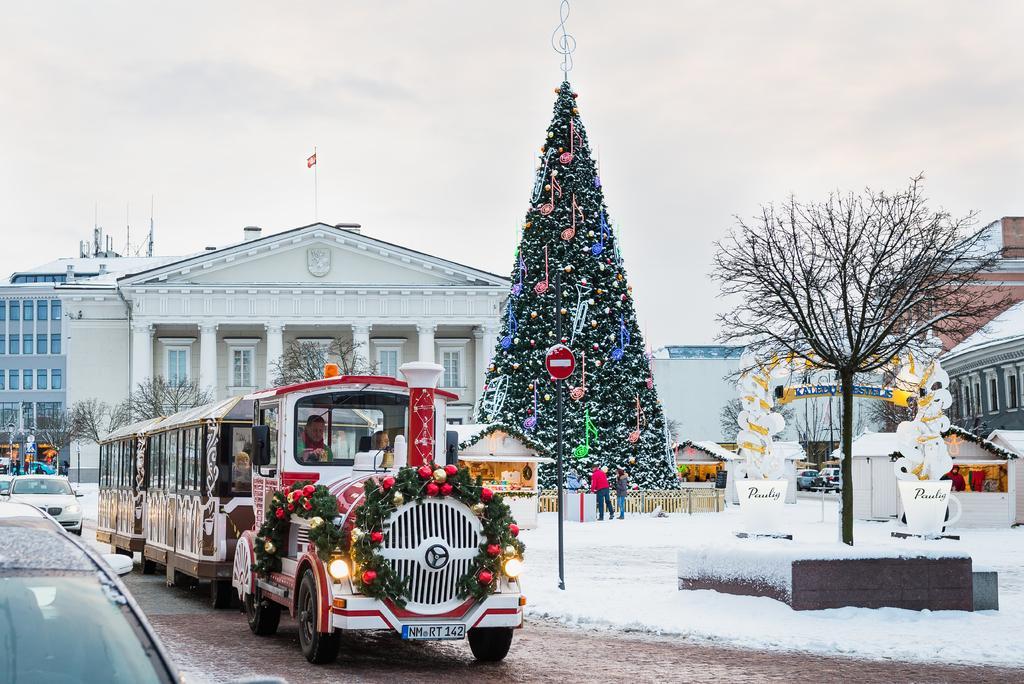Describe this image in one or two sentences. In the image we can see a vehicle, in the vehicle there are people sitting, this is a snow, tree, pole, building and windows of the building. This is a flag of a country and a sky. 